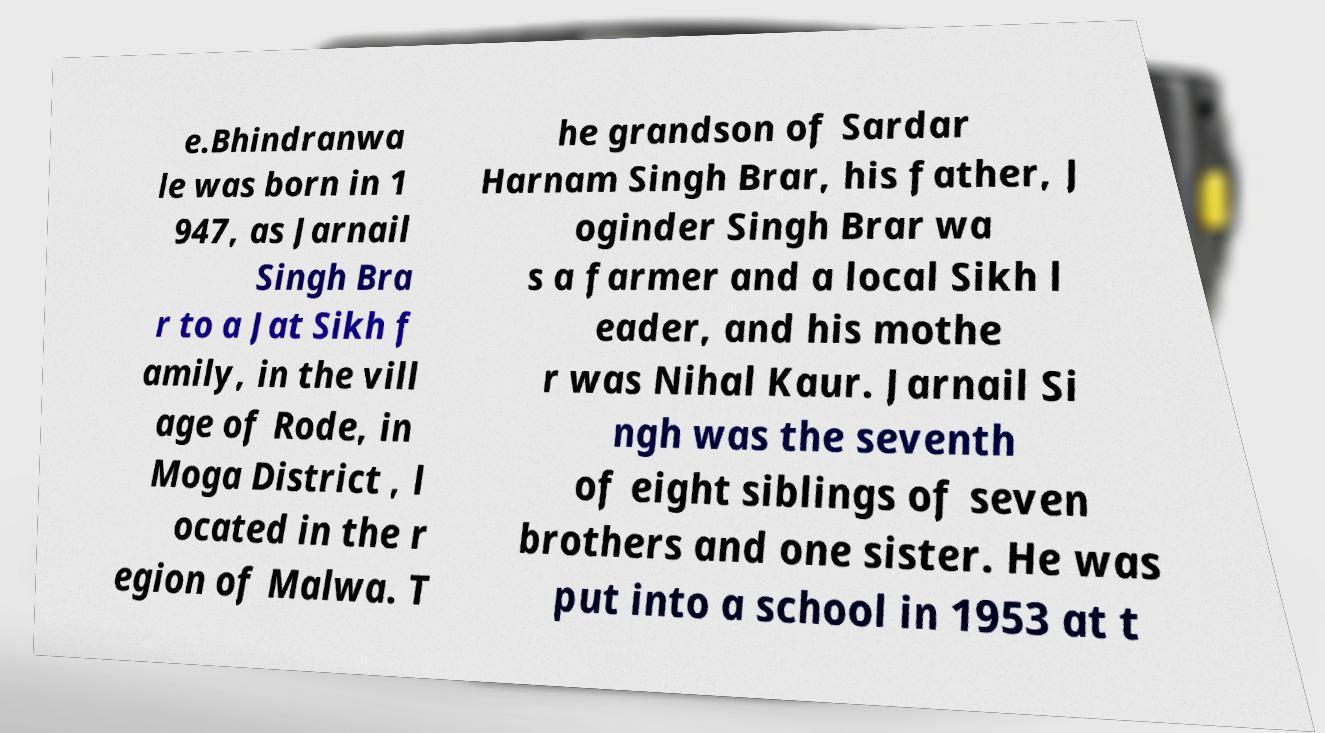Can you read and provide the text displayed in the image?This photo seems to have some interesting text. Can you extract and type it out for me? e.Bhindranwa le was born in 1 947, as Jarnail Singh Bra r to a Jat Sikh f amily, in the vill age of Rode, in Moga District , l ocated in the r egion of Malwa. T he grandson of Sardar Harnam Singh Brar, his father, J oginder Singh Brar wa s a farmer and a local Sikh l eader, and his mothe r was Nihal Kaur. Jarnail Si ngh was the seventh of eight siblings of seven brothers and one sister. He was put into a school in 1953 at t 